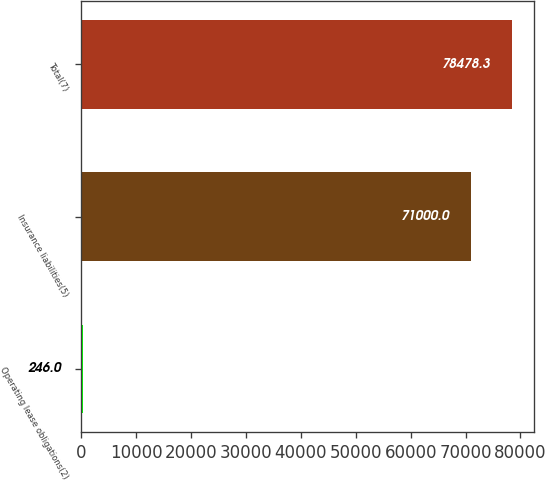Convert chart to OTSL. <chart><loc_0><loc_0><loc_500><loc_500><bar_chart><fcel>Operating lease obligations(2)<fcel>Insurance liabilities(5)<fcel>Total(7)<nl><fcel>246<fcel>71000<fcel>78478.3<nl></chart> 